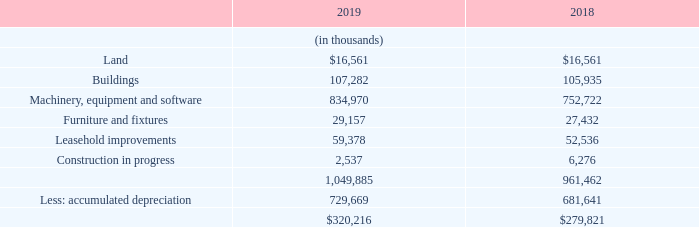G. PROPERTY, PLANT AND EQUIPMENT
Property, plant and equipment, net consisted of the following at December 31, 2019 and 2018:
Depreciation of property, plant and equipment for the years ended December 31, 2019, 2018, and 2017 was $70.8 million, $67.4 million, and $66.1 million, respectively. As of December 31, 2019 and 2018, the gross book value included in machinery and equipment for internally manufactured test systems being leased by customers was $5.4 million and $5.5 million, respectively. As of December 31, 2019 and 2018, the accumulated depreciation on these test systems was $5.1 million and $5.2 million, respectively.
What was the amount of Depreciation of property, plant and equipment in 2019? $70.8 million. What was the accumulated depreciation on the test systems in 2019? $5.1 million. In which years was Property, plant and equipment, net calculated? 2019, 2018. In which year was Construction in progress larger? 6,276>2,537
Answer: 2018. What was the change in the amount of Land from 2018 to 2019?
Answer scale should be: thousand. 16,561-16,561
Answer: 0. What was the percentage change in the amount of Land from 2018 to 2019?
Answer scale should be: percent. (16,561-16,561)/16,561
Answer: 0. 